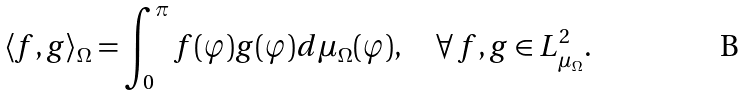<formula> <loc_0><loc_0><loc_500><loc_500>\langle f , g \rangle _ { \Omega } = \int _ { 0 } ^ { \pi } f ( \varphi ) g ( \varphi ) d \mu _ { \Omega } ( \varphi ) , \quad \forall \, f , g \in L ^ { 2 } _ { \mu _ { \Omega } } .</formula> 